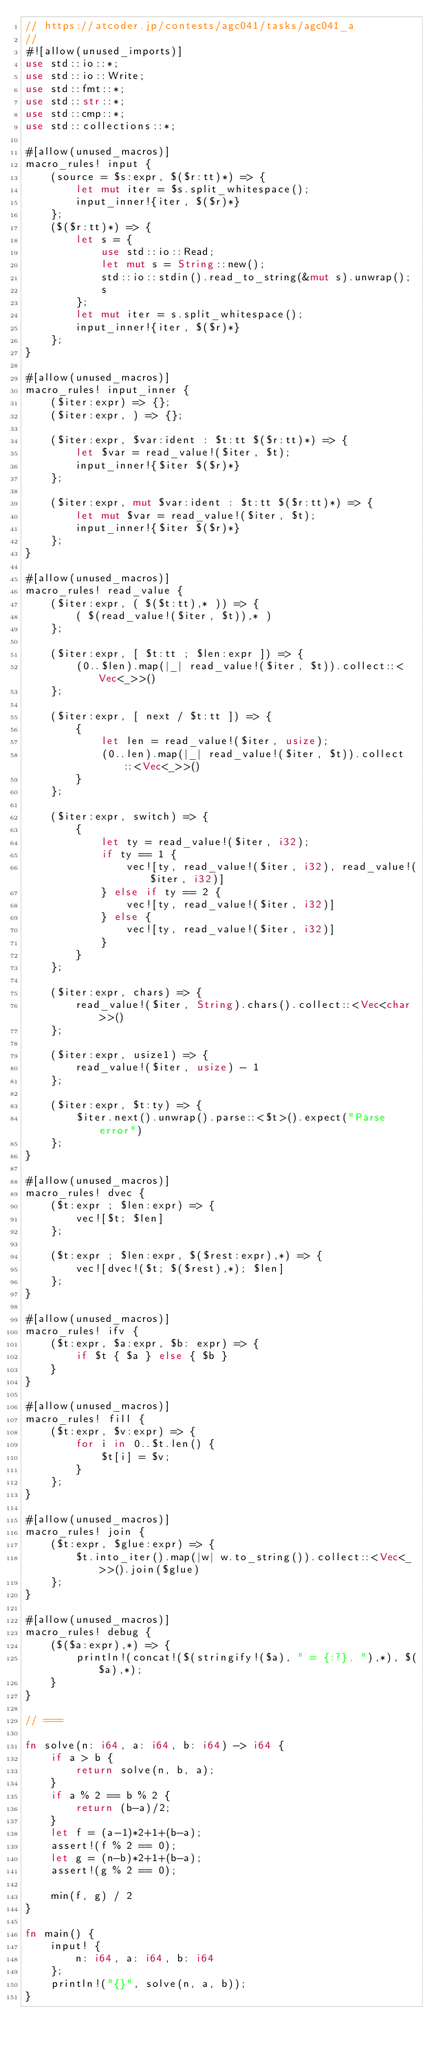<code> <loc_0><loc_0><loc_500><loc_500><_Rust_>// https://atcoder.jp/contests/agc041/tasks/agc041_a
//
#![allow(unused_imports)]
use std::io::*;
use std::io::Write;
use std::fmt::*;
use std::str::*;
use std::cmp::*;
use std::collections::*;

#[allow(unused_macros)]
macro_rules! input {
    (source = $s:expr, $($r:tt)*) => {
        let mut iter = $s.split_whitespace();
        input_inner!{iter, $($r)*}
    };
    ($($r:tt)*) => {
        let s = {
            use std::io::Read;
            let mut s = String::new();
            std::io::stdin().read_to_string(&mut s).unwrap();
            s
        };
        let mut iter = s.split_whitespace();
        input_inner!{iter, $($r)*}
    };
}

#[allow(unused_macros)]
macro_rules! input_inner {
    ($iter:expr) => {};
    ($iter:expr, ) => {};

    ($iter:expr, $var:ident : $t:tt $($r:tt)*) => {
        let $var = read_value!($iter, $t);
        input_inner!{$iter $($r)*}
    };

    ($iter:expr, mut $var:ident : $t:tt $($r:tt)*) => {
        let mut $var = read_value!($iter, $t);
        input_inner!{$iter $($r)*}
    };
}

#[allow(unused_macros)]
macro_rules! read_value {
    ($iter:expr, ( $($t:tt),* )) => {
        ( $(read_value!($iter, $t)),* )
    };

    ($iter:expr, [ $t:tt ; $len:expr ]) => {
        (0..$len).map(|_| read_value!($iter, $t)).collect::<Vec<_>>()
    };

    ($iter:expr, [ next / $t:tt ]) => {
        {
            let len = read_value!($iter, usize);
            (0..len).map(|_| read_value!($iter, $t)).collect::<Vec<_>>()
        }
    };

    ($iter:expr, switch) => {
        {
            let ty = read_value!($iter, i32);
            if ty == 1 {
                vec![ty, read_value!($iter, i32), read_value!($iter, i32)]
            } else if ty == 2 {
                vec![ty, read_value!($iter, i32)]
            } else {
                vec![ty, read_value!($iter, i32)]
            }
        }
    };

    ($iter:expr, chars) => {
        read_value!($iter, String).chars().collect::<Vec<char>>()
    };

    ($iter:expr, usize1) => {
        read_value!($iter, usize) - 1
    };

    ($iter:expr, $t:ty) => {
        $iter.next().unwrap().parse::<$t>().expect("Parse error")
    };
}

#[allow(unused_macros)]
macro_rules! dvec {
    ($t:expr ; $len:expr) => {
        vec![$t; $len]
    };

    ($t:expr ; $len:expr, $($rest:expr),*) => {
        vec![dvec!($t; $($rest),*); $len]
    };
}

#[allow(unused_macros)]
macro_rules! ifv {
    ($t:expr, $a:expr, $b: expr) => {
        if $t { $a } else { $b }
    }
}

#[allow(unused_macros)]
macro_rules! fill {
    ($t:expr, $v:expr) => {
        for i in 0..$t.len() {
            $t[i] = $v;
        }
    };
}

#[allow(unused_macros)]
macro_rules! join {
    ($t:expr, $glue:expr) => {
        $t.into_iter().map(|w| w.to_string()).collect::<Vec<_>>().join($glue)
    };
}

#[allow(unused_macros)]
macro_rules! debug {
    ($($a:expr),*) => {
        println!(concat!($(stringify!($a), " = {:?}, "),*), $($a),*);
    }
}

// ===

fn solve(n: i64, a: i64, b: i64) -> i64 {
    if a > b {
        return solve(n, b, a);
    }
    if a % 2 == b % 2 {
        return (b-a)/2;
    }
    let f = (a-1)*2+1+(b-a);
    assert!(f % 2 == 0);
    let g = (n-b)*2+1+(b-a);
    assert!(g % 2 == 0);

    min(f, g) / 2
}

fn main() {
    input! {
        n: i64, a: i64, b: i64
    };
    println!("{}", solve(n, a, b));
}
</code> 